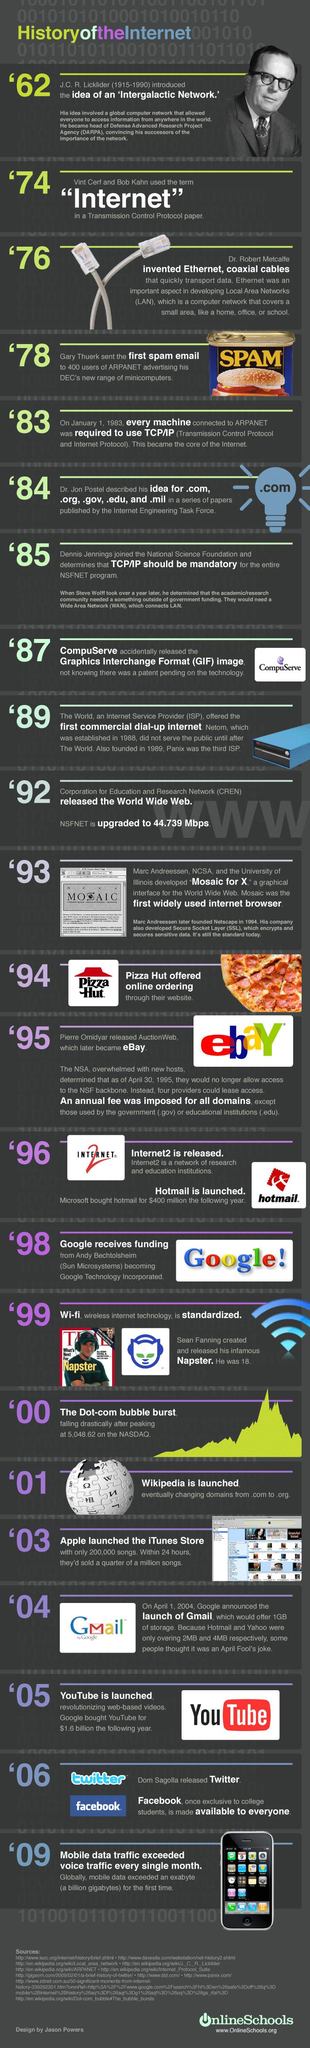Outline some significant characteristics in this image. Mosaic was the first browser, preceding Google, Internet 2, and other browsers that followed. The concept of the internet was conceived in 1962. The logo of a company features a red hat, and the name of the company is Pizza Hut. The year that is considered the genesis of the .com domain is 1984. The canned food label reads, "SPAM...". 